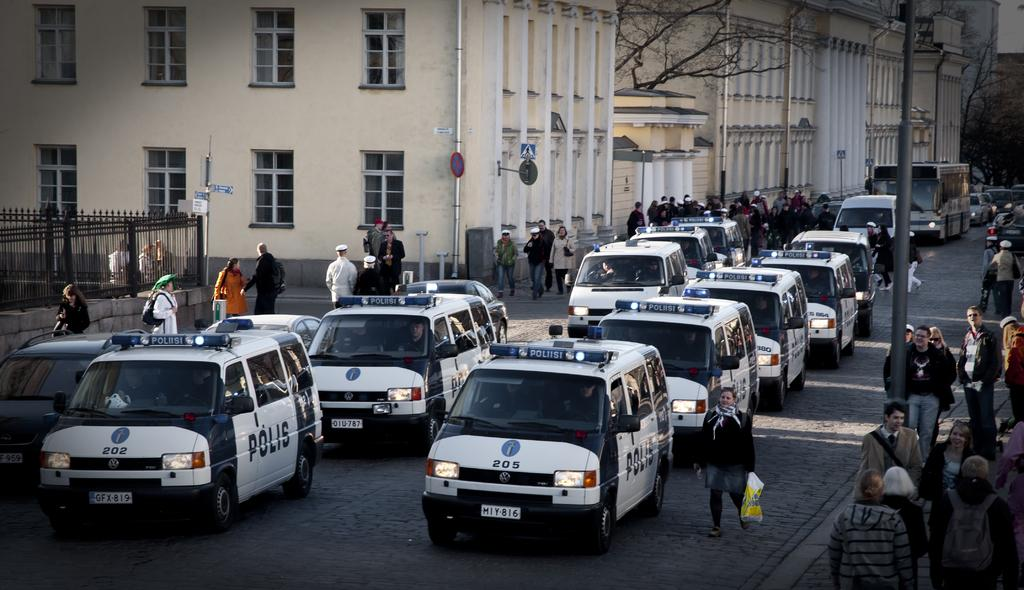<image>
Write a terse but informative summary of the picture. A street full of Polis vehicles, the closest is number 205. 